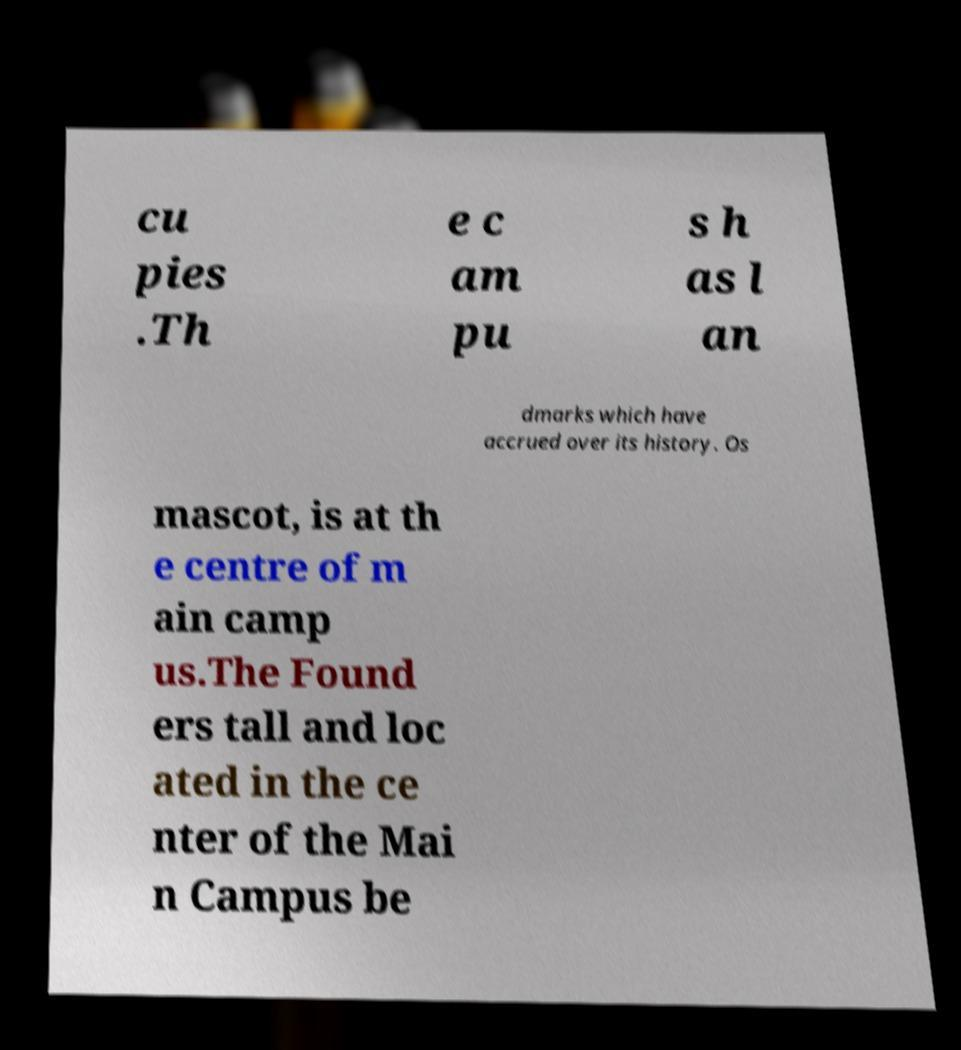Please identify and transcribe the text found in this image. cu pies .Th e c am pu s h as l an dmarks which have accrued over its history. Os mascot, is at th e centre of m ain camp us.The Found ers tall and loc ated in the ce nter of the Mai n Campus be 